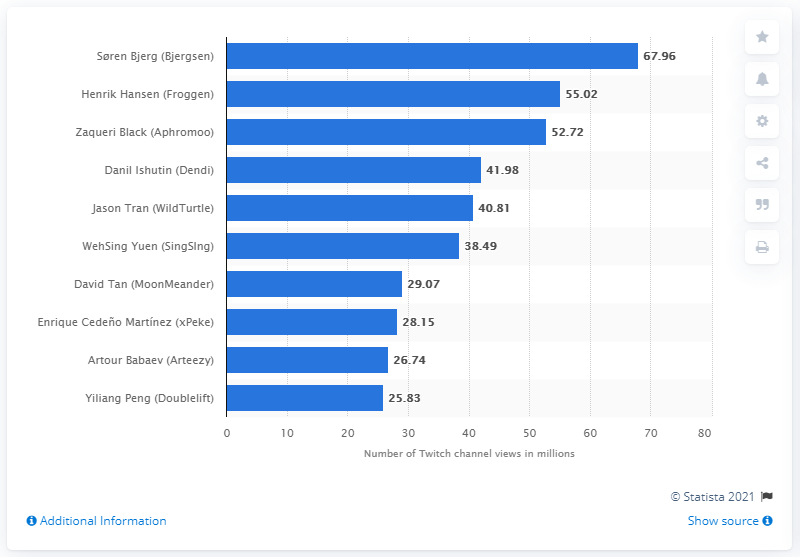List a handful of essential elements in this visual. According to the provided data, Henrik Hansen's Twitch channel was viewed a total of 55.02 times. According to Twitch data, S ren Bjerg had 67,960 channel views. 